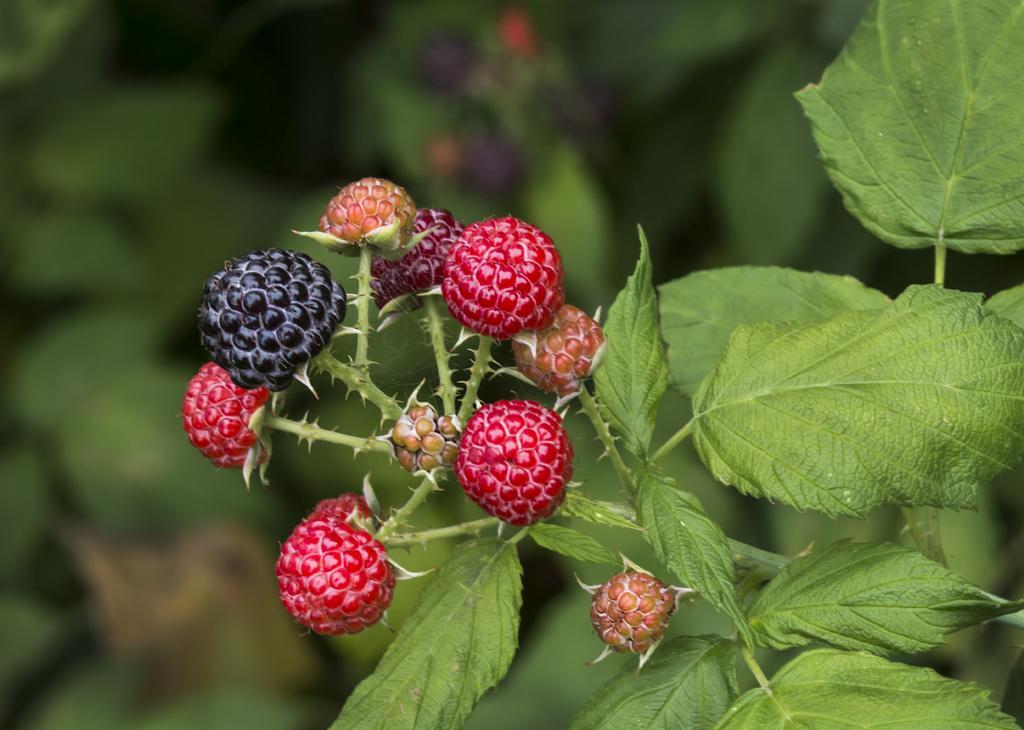Describe this image in one or two sentences. In this picture we can see fruits, leaves and blurry background. 